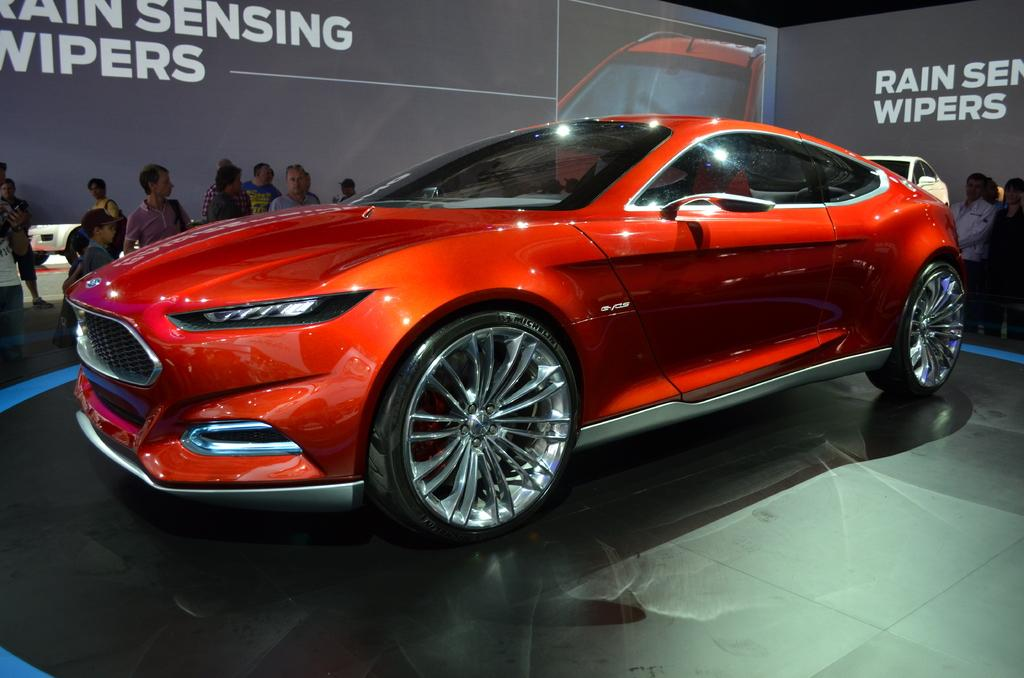What type of vehicle is in the image? There is a red car in the image. Where is the car located? The car is on a path. What else can be seen on the path in the image? There are groups of people standing on the path behind the car. What is visible behind the people in the image? There is a board visible in the image behind the people. What type of noise can be heard coming from the drain in the image? There is no drain present in the image, so it is not possible to determine if any noise is coming from it. 